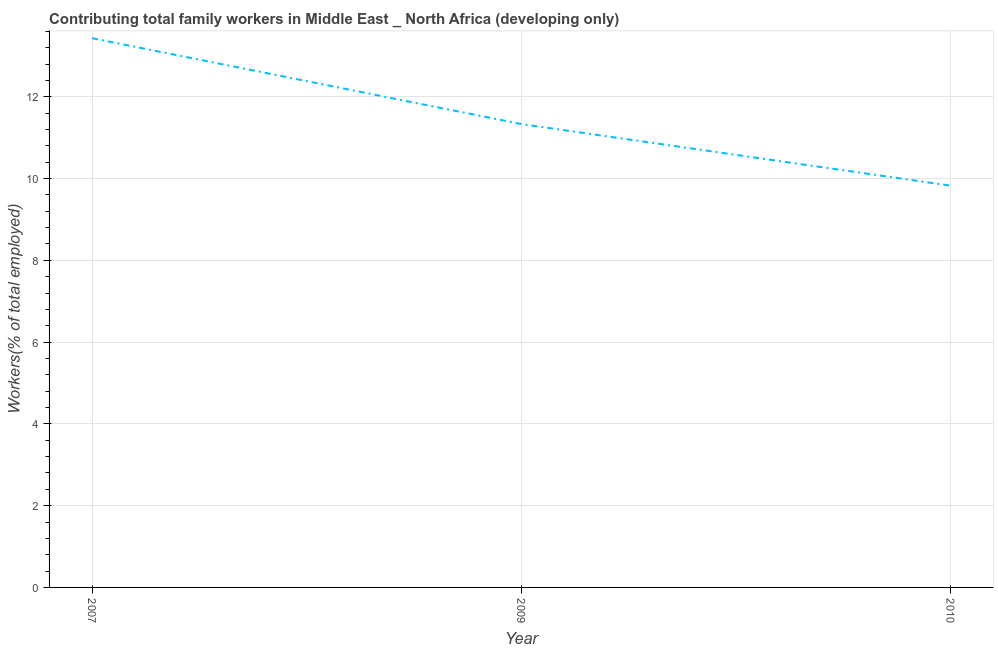What is the contributing family workers in 2007?
Provide a succinct answer. 13.43. Across all years, what is the maximum contributing family workers?
Make the answer very short. 13.43. Across all years, what is the minimum contributing family workers?
Your answer should be very brief. 9.83. What is the sum of the contributing family workers?
Your response must be concise. 34.59. What is the difference between the contributing family workers in 2007 and 2009?
Your answer should be compact. 2.1. What is the average contributing family workers per year?
Your answer should be very brief. 11.53. What is the median contributing family workers?
Ensure brevity in your answer.  11.33. What is the ratio of the contributing family workers in 2007 to that in 2010?
Make the answer very short. 1.37. What is the difference between the highest and the second highest contributing family workers?
Keep it short and to the point. 2.1. What is the difference between the highest and the lowest contributing family workers?
Provide a short and direct response. 3.61. Are the values on the major ticks of Y-axis written in scientific E-notation?
Give a very brief answer. No. Does the graph contain any zero values?
Ensure brevity in your answer.  No. Does the graph contain grids?
Ensure brevity in your answer.  Yes. What is the title of the graph?
Give a very brief answer. Contributing total family workers in Middle East _ North Africa (developing only). What is the label or title of the Y-axis?
Your answer should be compact. Workers(% of total employed). What is the Workers(% of total employed) of 2007?
Make the answer very short. 13.43. What is the Workers(% of total employed) in 2009?
Give a very brief answer. 11.33. What is the Workers(% of total employed) of 2010?
Give a very brief answer. 9.83. What is the difference between the Workers(% of total employed) in 2007 and 2009?
Offer a terse response. 2.1. What is the difference between the Workers(% of total employed) in 2007 and 2010?
Provide a succinct answer. 3.61. What is the difference between the Workers(% of total employed) in 2009 and 2010?
Make the answer very short. 1.51. What is the ratio of the Workers(% of total employed) in 2007 to that in 2009?
Your response must be concise. 1.19. What is the ratio of the Workers(% of total employed) in 2007 to that in 2010?
Keep it short and to the point. 1.37. What is the ratio of the Workers(% of total employed) in 2009 to that in 2010?
Offer a very short reply. 1.15. 